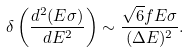<formula> <loc_0><loc_0><loc_500><loc_500>\delta \left ( \frac { d ^ { 2 } ( E \sigma ) } { d E ^ { 2 } } \right ) \sim \frac { \sqrt { 6 } f E \sigma } { ( \Delta E ) ^ { 2 } } .</formula> 